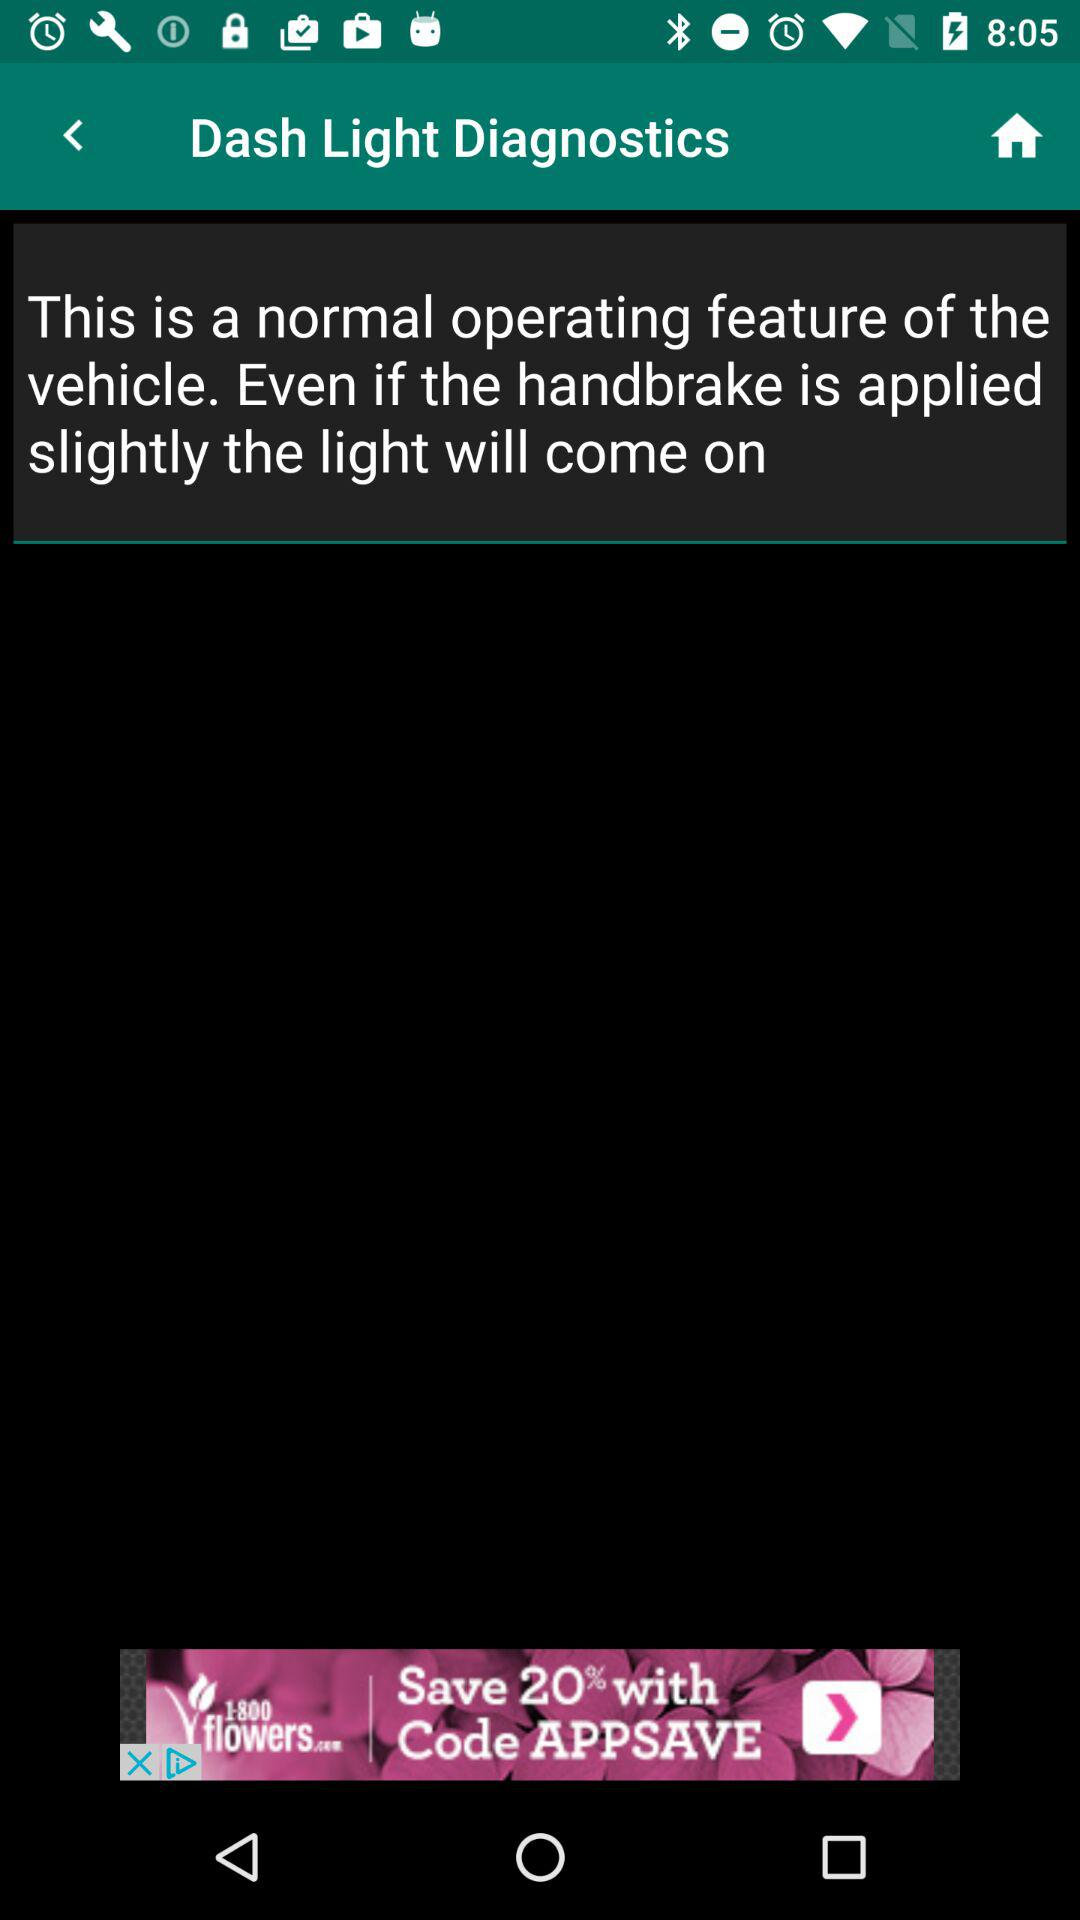How much can be saved by using the code? By using the code, 20% can be saved. 